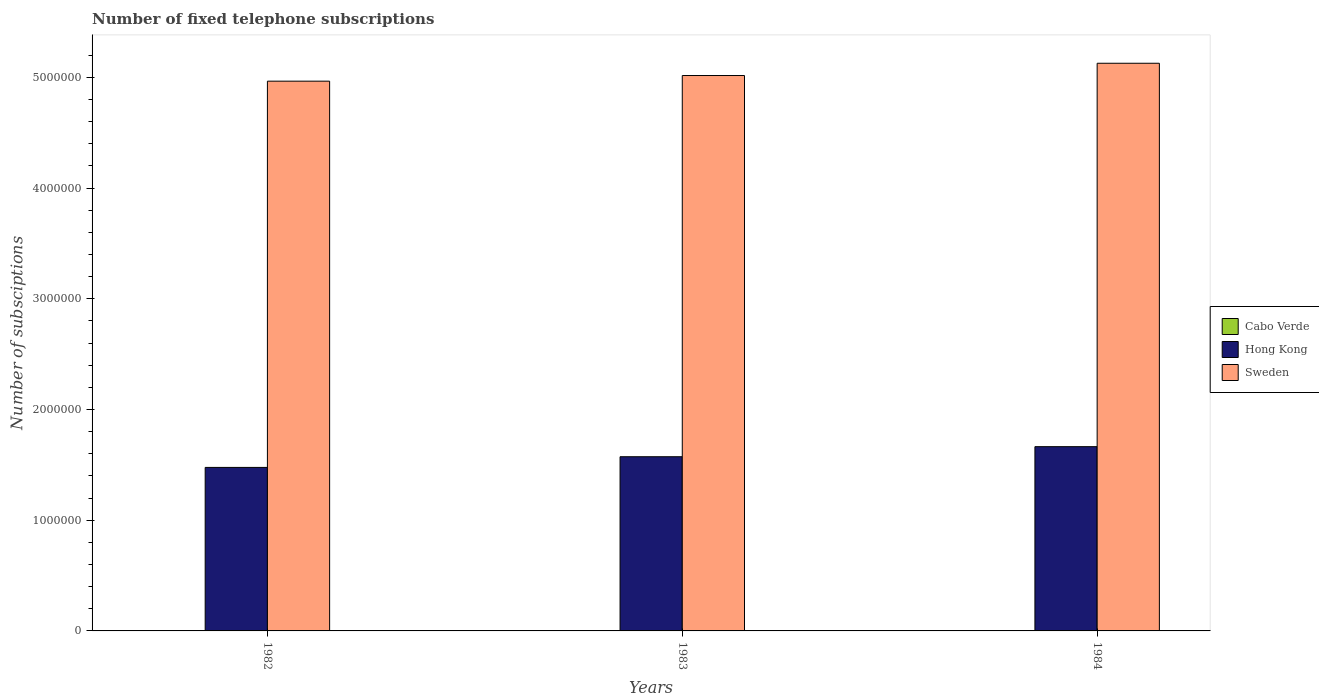How many different coloured bars are there?
Your answer should be compact. 3. Are the number of bars on each tick of the X-axis equal?
Ensure brevity in your answer.  Yes. How many bars are there on the 3rd tick from the left?
Your response must be concise. 3. What is the label of the 2nd group of bars from the left?
Give a very brief answer. 1983. In how many cases, is the number of bars for a given year not equal to the number of legend labels?
Your answer should be very brief. 0. What is the number of fixed telephone subscriptions in Hong Kong in 1983?
Provide a succinct answer. 1.57e+06. Across all years, what is the maximum number of fixed telephone subscriptions in Cabo Verde?
Provide a succinct answer. 2190. Across all years, what is the minimum number of fixed telephone subscriptions in Cabo Verde?
Provide a succinct answer. 1700. In which year was the number of fixed telephone subscriptions in Hong Kong maximum?
Your answer should be compact. 1984. What is the total number of fixed telephone subscriptions in Hong Kong in the graph?
Make the answer very short. 4.71e+06. What is the difference between the number of fixed telephone subscriptions in Hong Kong in 1982 and that in 1984?
Offer a very short reply. -1.87e+05. What is the difference between the number of fixed telephone subscriptions in Hong Kong in 1983 and the number of fixed telephone subscriptions in Cabo Verde in 1984?
Your response must be concise. 1.57e+06. What is the average number of fixed telephone subscriptions in Sweden per year?
Make the answer very short. 5.04e+06. In the year 1982, what is the difference between the number of fixed telephone subscriptions in Cabo Verde and number of fixed telephone subscriptions in Hong Kong?
Provide a short and direct response. -1.48e+06. What is the ratio of the number of fixed telephone subscriptions in Hong Kong in 1982 to that in 1984?
Offer a very short reply. 0.89. Is the number of fixed telephone subscriptions in Cabo Verde in 1982 less than that in 1984?
Keep it short and to the point. Yes. What is the difference between the highest and the second highest number of fixed telephone subscriptions in Sweden?
Your answer should be compact. 1.11e+05. What is the difference between the highest and the lowest number of fixed telephone subscriptions in Cabo Verde?
Your answer should be very brief. 490. In how many years, is the number of fixed telephone subscriptions in Cabo Verde greater than the average number of fixed telephone subscriptions in Cabo Verde taken over all years?
Provide a succinct answer. 1. Is the sum of the number of fixed telephone subscriptions in Hong Kong in 1982 and 1984 greater than the maximum number of fixed telephone subscriptions in Cabo Verde across all years?
Your answer should be very brief. Yes. What does the 2nd bar from the left in 1983 represents?
Your response must be concise. Hong Kong. What does the 2nd bar from the right in 1984 represents?
Offer a terse response. Hong Kong. How many bars are there?
Make the answer very short. 9. How many years are there in the graph?
Give a very brief answer. 3. What is the difference between two consecutive major ticks on the Y-axis?
Offer a very short reply. 1.00e+06. Does the graph contain grids?
Give a very brief answer. No. Where does the legend appear in the graph?
Make the answer very short. Center right. How are the legend labels stacked?
Give a very brief answer. Vertical. What is the title of the graph?
Offer a very short reply. Number of fixed telephone subscriptions. What is the label or title of the X-axis?
Make the answer very short. Years. What is the label or title of the Y-axis?
Your answer should be very brief. Number of subsciptions. What is the Number of subsciptions in Cabo Verde in 1982?
Your answer should be very brief. 1700. What is the Number of subsciptions of Hong Kong in 1982?
Your response must be concise. 1.48e+06. What is the Number of subsciptions of Sweden in 1982?
Offer a very short reply. 4.97e+06. What is the Number of subsciptions of Cabo Verde in 1983?
Keep it short and to the point. 1890. What is the Number of subsciptions of Hong Kong in 1983?
Provide a succinct answer. 1.57e+06. What is the Number of subsciptions in Sweden in 1983?
Your answer should be very brief. 5.02e+06. What is the Number of subsciptions in Cabo Verde in 1984?
Your answer should be compact. 2190. What is the Number of subsciptions in Hong Kong in 1984?
Provide a succinct answer. 1.66e+06. What is the Number of subsciptions in Sweden in 1984?
Provide a succinct answer. 5.13e+06. Across all years, what is the maximum Number of subsciptions of Cabo Verde?
Offer a very short reply. 2190. Across all years, what is the maximum Number of subsciptions of Hong Kong?
Provide a short and direct response. 1.66e+06. Across all years, what is the maximum Number of subsciptions in Sweden?
Keep it short and to the point. 5.13e+06. Across all years, what is the minimum Number of subsciptions of Cabo Verde?
Your answer should be compact. 1700. Across all years, what is the minimum Number of subsciptions of Hong Kong?
Provide a short and direct response. 1.48e+06. Across all years, what is the minimum Number of subsciptions of Sweden?
Provide a short and direct response. 4.97e+06. What is the total Number of subsciptions in Cabo Verde in the graph?
Your response must be concise. 5780. What is the total Number of subsciptions of Hong Kong in the graph?
Offer a terse response. 4.71e+06. What is the total Number of subsciptions of Sweden in the graph?
Provide a succinct answer. 1.51e+07. What is the difference between the Number of subsciptions of Cabo Verde in 1982 and that in 1983?
Provide a short and direct response. -190. What is the difference between the Number of subsciptions in Hong Kong in 1982 and that in 1983?
Offer a very short reply. -9.65e+04. What is the difference between the Number of subsciptions in Sweden in 1982 and that in 1983?
Give a very brief answer. -5.09e+04. What is the difference between the Number of subsciptions of Cabo Verde in 1982 and that in 1984?
Make the answer very short. -490. What is the difference between the Number of subsciptions of Hong Kong in 1982 and that in 1984?
Ensure brevity in your answer.  -1.87e+05. What is the difference between the Number of subsciptions in Sweden in 1982 and that in 1984?
Keep it short and to the point. -1.62e+05. What is the difference between the Number of subsciptions in Cabo Verde in 1983 and that in 1984?
Offer a very short reply. -300. What is the difference between the Number of subsciptions of Hong Kong in 1983 and that in 1984?
Offer a very short reply. -9.10e+04. What is the difference between the Number of subsciptions in Sweden in 1983 and that in 1984?
Ensure brevity in your answer.  -1.11e+05. What is the difference between the Number of subsciptions in Cabo Verde in 1982 and the Number of subsciptions in Hong Kong in 1983?
Offer a terse response. -1.57e+06. What is the difference between the Number of subsciptions in Cabo Verde in 1982 and the Number of subsciptions in Sweden in 1983?
Ensure brevity in your answer.  -5.02e+06. What is the difference between the Number of subsciptions of Hong Kong in 1982 and the Number of subsciptions of Sweden in 1983?
Make the answer very short. -3.54e+06. What is the difference between the Number of subsciptions of Cabo Verde in 1982 and the Number of subsciptions of Hong Kong in 1984?
Keep it short and to the point. -1.66e+06. What is the difference between the Number of subsciptions in Cabo Verde in 1982 and the Number of subsciptions in Sweden in 1984?
Offer a very short reply. -5.13e+06. What is the difference between the Number of subsciptions of Hong Kong in 1982 and the Number of subsciptions of Sweden in 1984?
Provide a short and direct response. -3.65e+06. What is the difference between the Number of subsciptions in Cabo Verde in 1983 and the Number of subsciptions in Hong Kong in 1984?
Keep it short and to the point. -1.66e+06. What is the difference between the Number of subsciptions of Cabo Verde in 1983 and the Number of subsciptions of Sweden in 1984?
Ensure brevity in your answer.  -5.13e+06. What is the difference between the Number of subsciptions in Hong Kong in 1983 and the Number of subsciptions in Sweden in 1984?
Provide a succinct answer. -3.55e+06. What is the average Number of subsciptions in Cabo Verde per year?
Provide a succinct answer. 1926.67. What is the average Number of subsciptions of Hong Kong per year?
Give a very brief answer. 1.57e+06. What is the average Number of subsciptions in Sweden per year?
Make the answer very short. 5.04e+06. In the year 1982, what is the difference between the Number of subsciptions in Cabo Verde and Number of subsciptions in Hong Kong?
Your answer should be compact. -1.48e+06. In the year 1982, what is the difference between the Number of subsciptions of Cabo Verde and Number of subsciptions of Sweden?
Make the answer very short. -4.96e+06. In the year 1982, what is the difference between the Number of subsciptions of Hong Kong and Number of subsciptions of Sweden?
Your response must be concise. -3.49e+06. In the year 1983, what is the difference between the Number of subsciptions in Cabo Verde and Number of subsciptions in Hong Kong?
Keep it short and to the point. -1.57e+06. In the year 1983, what is the difference between the Number of subsciptions of Cabo Verde and Number of subsciptions of Sweden?
Give a very brief answer. -5.01e+06. In the year 1983, what is the difference between the Number of subsciptions in Hong Kong and Number of subsciptions in Sweden?
Offer a terse response. -3.44e+06. In the year 1984, what is the difference between the Number of subsciptions of Cabo Verde and Number of subsciptions of Hong Kong?
Provide a short and direct response. -1.66e+06. In the year 1984, what is the difference between the Number of subsciptions of Cabo Verde and Number of subsciptions of Sweden?
Your answer should be compact. -5.13e+06. In the year 1984, what is the difference between the Number of subsciptions of Hong Kong and Number of subsciptions of Sweden?
Provide a succinct answer. -3.46e+06. What is the ratio of the Number of subsciptions in Cabo Verde in 1982 to that in 1983?
Keep it short and to the point. 0.9. What is the ratio of the Number of subsciptions of Hong Kong in 1982 to that in 1983?
Ensure brevity in your answer.  0.94. What is the ratio of the Number of subsciptions of Cabo Verde in 1982 to that in 1984?
Offer a terse response. 0.78. What is the ratio of the Number of subsciptions in Hong Kong in 1982 to that in 1984?
Offer a very short reply. 0.89. What is the ratio of the Number of subsciptions of Sweden in 1982 to that in 1984?
Provide a succinct answer. 0.97. What is the ratio of the Number of subsciptions of Cabo Verde in 1983 to that in 1984?
Your response must be concise. 0.86. What is the ratio of the Number of subsciptions of Hong Kong in 1983 to that in 1984?
Your response must be concise. 0.95. What is the ratio of the Number of subsciptions in Sweden in 1983 to that in 1984?
Offer a terse response. 0.98. What is the difference between the highest and the second highest Number of subsciptions of Cabo Verde?
Offer a very short reply. 300. What is the difference between the highest and the second highest Number of subsciptions in Hong Kong?
Provide a succinct answer. 9.10e+04. What is the difference between the highest and the second highest Number of subsciptions of Sweden?
Offer a very short reply. 1.11e+05. What is the difference between the highest and the lowest Number of subsciptions of Cabo Verde?
Your answer should be very brief. 490. What is the difference between the highest and the lowest Number of subsciptions in Hong Kong?
Your answer should be very brief. 1.87e+05. What is the difference between the highest and the lowest Number of subsciptions of Sweden?
Your answer should be compact. 1.62e+05. 